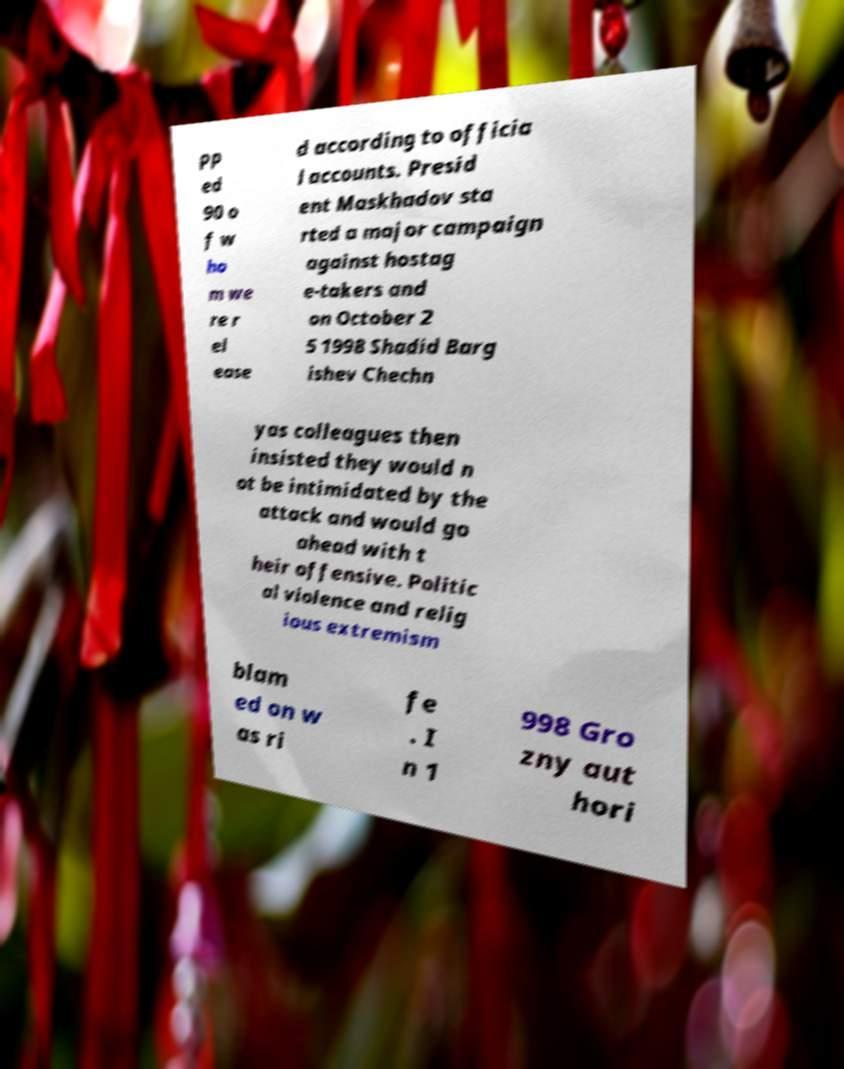There's text embedded in this image that I need extracted. Can you transcribe it verbatim? pp ed 90 o f w ho m we re r el ease d according to officia l accounts. Presid ent Maskhadov sta rted a major campaign against hostag e-takers and on October 2 5 1998 Shadid Barg ishev Chechn yas colleagues then insisted they would n ot be intimidated by the attack and would go ahead with t heir offensive. Politic al violence and relig ious extremism blam ed on w as ri fe . I n 1 998 Gro zny aut hori 